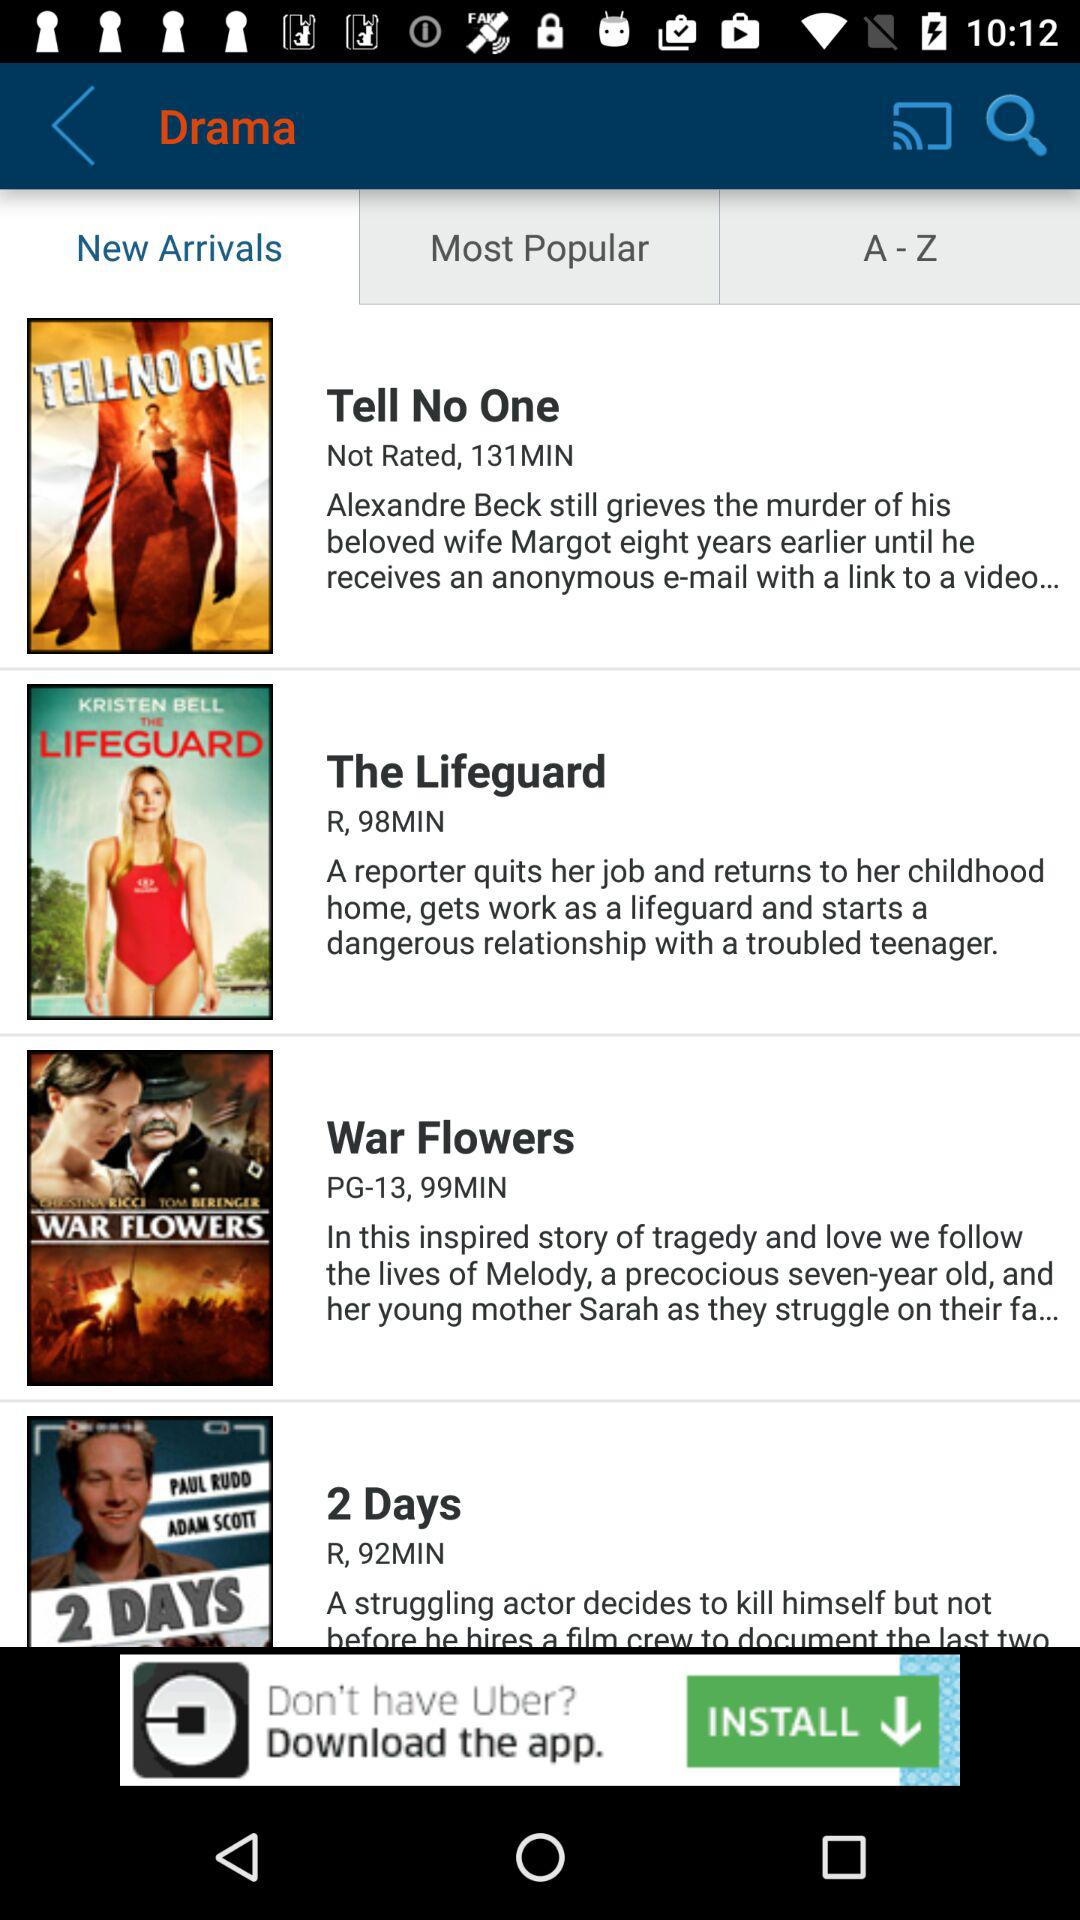How many more minutes are in the longest movie than the shortest movie?
Answer the question using a single word or phrase. 39 